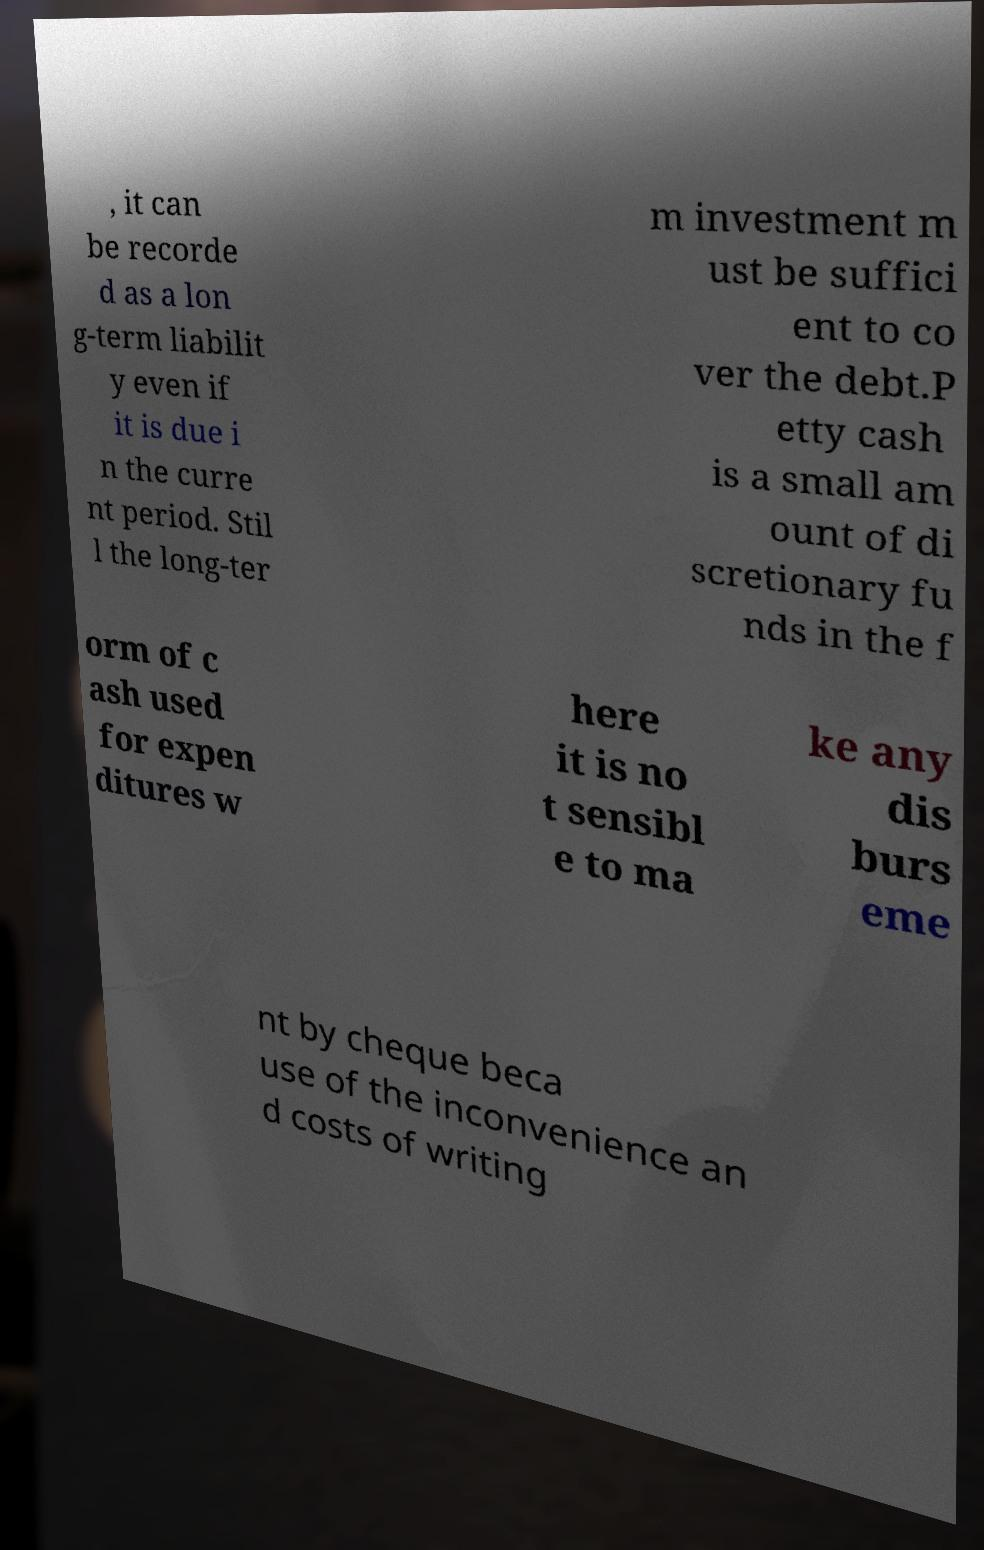Can you read and provide the text displayed in the image?This photo seems to have some interesting text. Can you extract and type it out for me? , it can be recorde d as a lon g-term liabilit y even if it is due i n the curre nt period. Stil l the long-ter m investment m ust be suffici ent to co ver the debt.P etty cash is a small am ount of di scretionary fu nds in the f orm of c ash used for expen ditures w here it is no t sensibl e to ma ke any dis burs eme nt by cheque beca use of the inconvenience an d costs of writing 